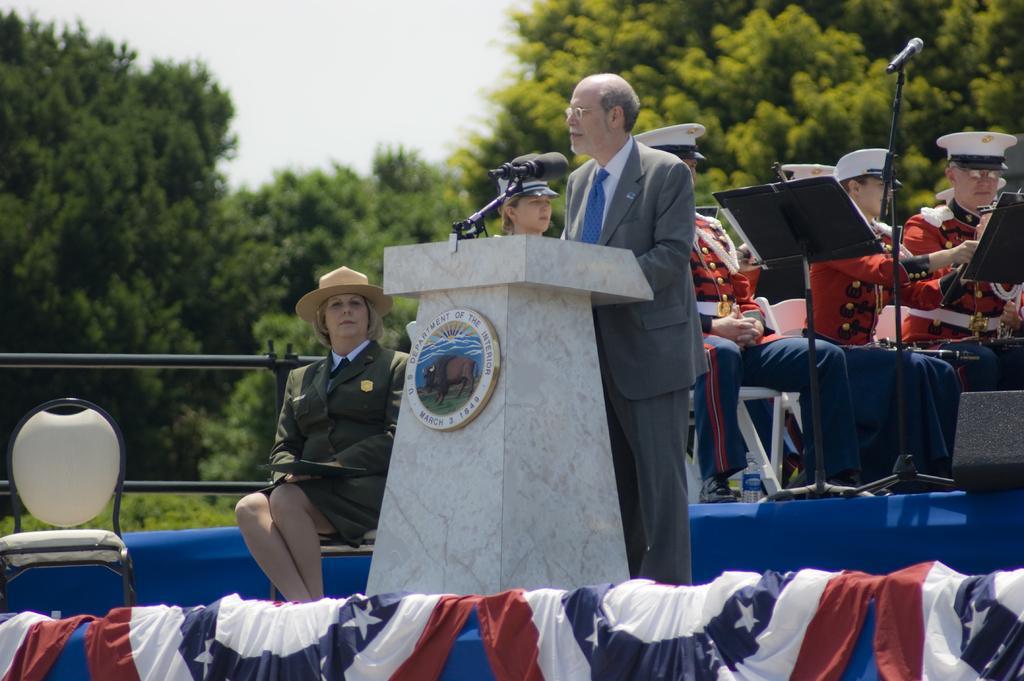Can you describe this image briefly? In this image we can see a man is standing, wearing grey color suit in front of the podium. Behind him so many people are sitting and playing music. Background of the image trees are present. Left side of the image one white color chair is there and one woman is sitting. She is wearing green color dress and brown hat. 